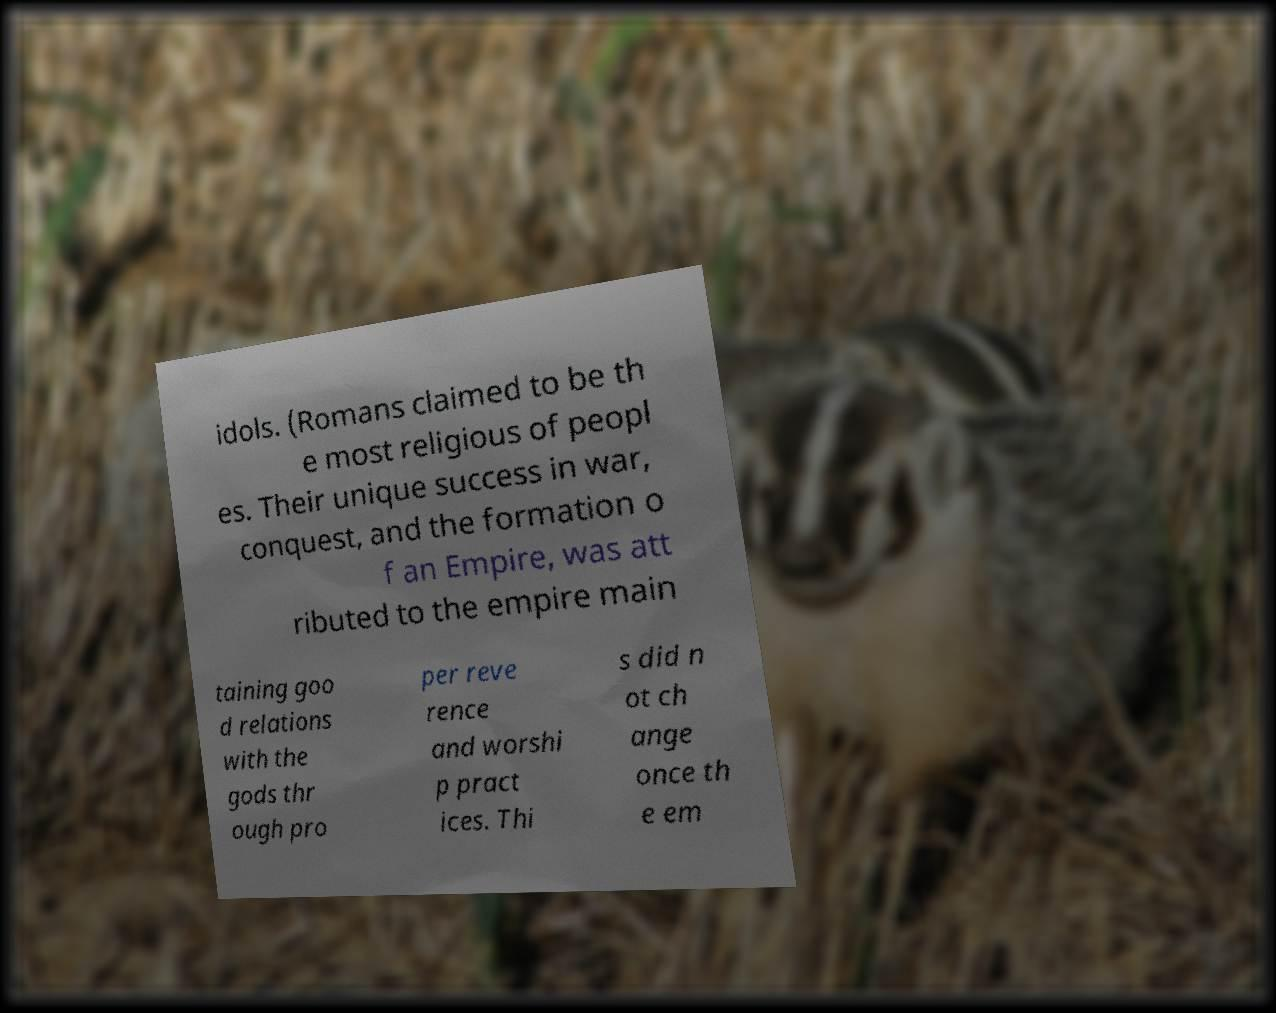Can you read and provide the text displayed in the image?This photo seems to have some interesting text. Can you extract and type it out for me? idols. (Romans claimed to be th e most religious of peopl es. Their unique success in war, conquest, and the formation o f an Empire, was att ributed to the empire main taining goo d relations with the gods thr ough pro per reve rence and worshi p pract ices. Thi s did n ot ch ange once th e em 